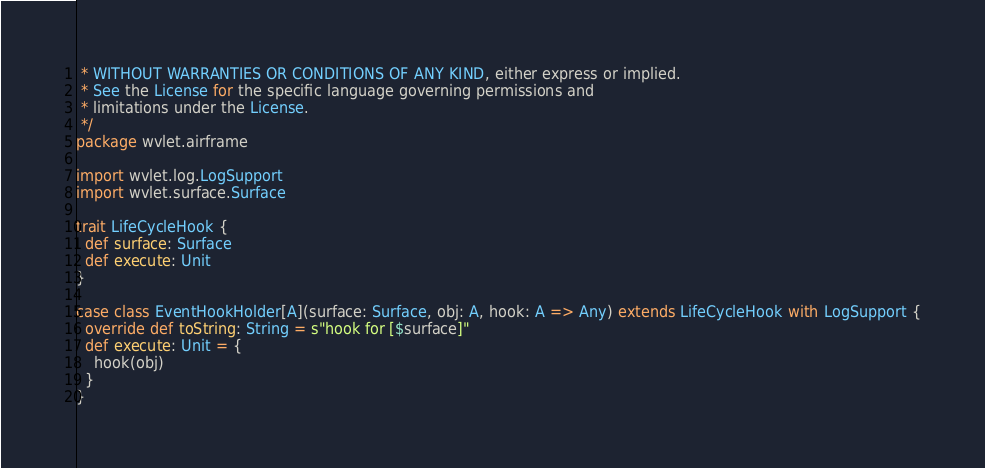Convert code to text. <code><loc_0><loc_0><loc_500><loc_500><_Scala_> * WITHOUT WARRANTIES OR CONDITIONS OF ANY KIND, either express or implied.
 * See the License for the specific language governing permissions and
 * limitations under the License.
 */
package wvlet.airframe

import wvlet.log.LogSupport
import wvlet.surface.Surface

trait LifeCycleHook {
  def surface: Surface
  def execute: Unit
}

case class EventHookHolder[A](surface: Surface, obj: A, hook: A => Any) extends LifeCycleHook with LogSupport {
  override def toString: String = s"hook for [$surface]"
  def execute: Unit = {
    hook(obj)
  }
}
</code> 